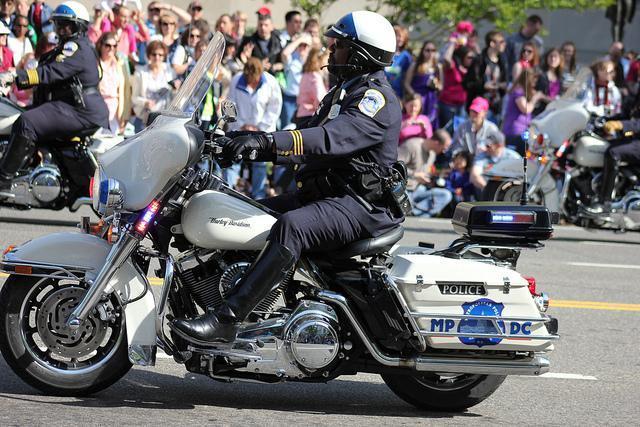How many people are in the picture?
Give a very brief answer. 6. How many motorcycles can be seen?
Give a very brief answer. 3. How many white cars are there?
Give a very brief answer. 0. 